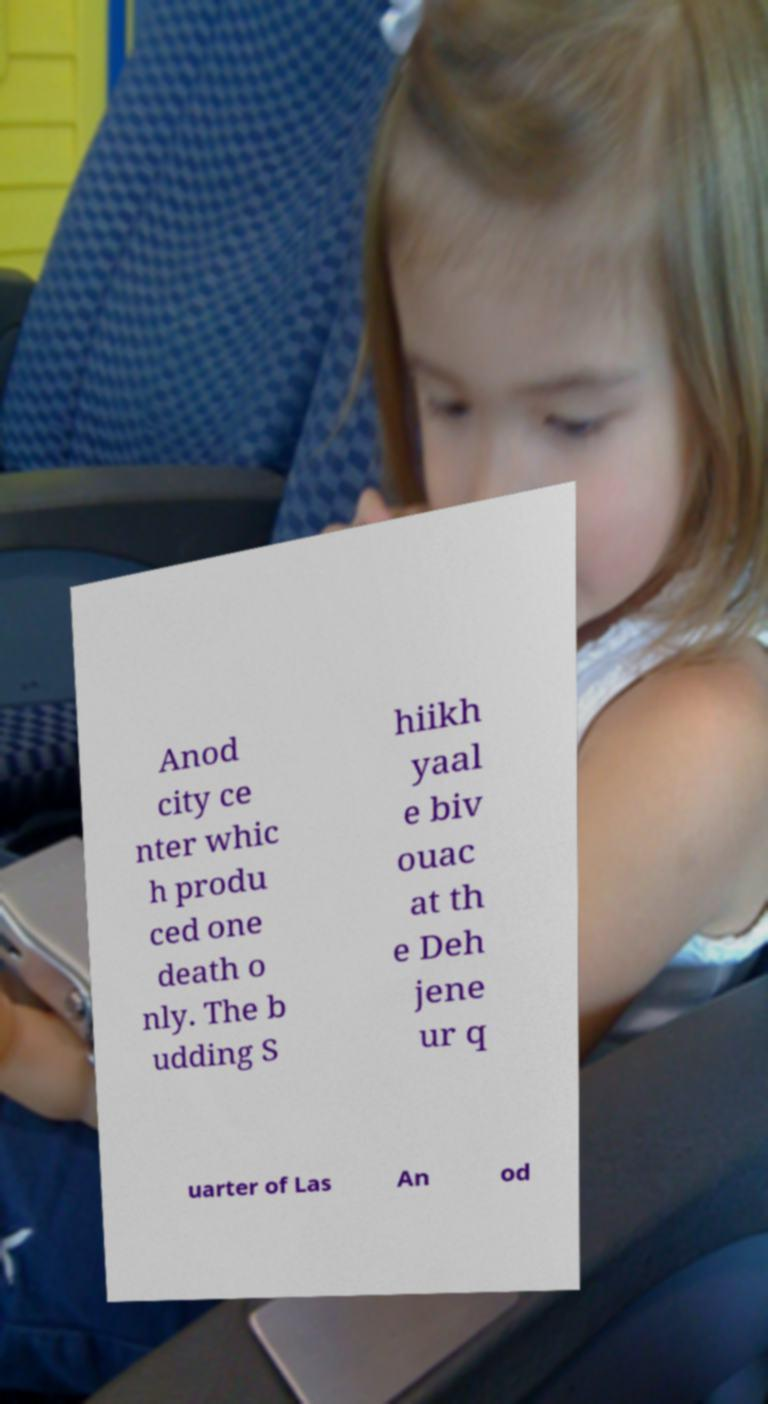Can you read and provide the text displayed in the image?This photo seems to have some interesting text. Can you extract and type it out for me? Anod city ce nter whic h produ ced one death o nly. The b udding S hiikh yaal e biv ouac at th e Deh jene ur q uarter of Las An od 